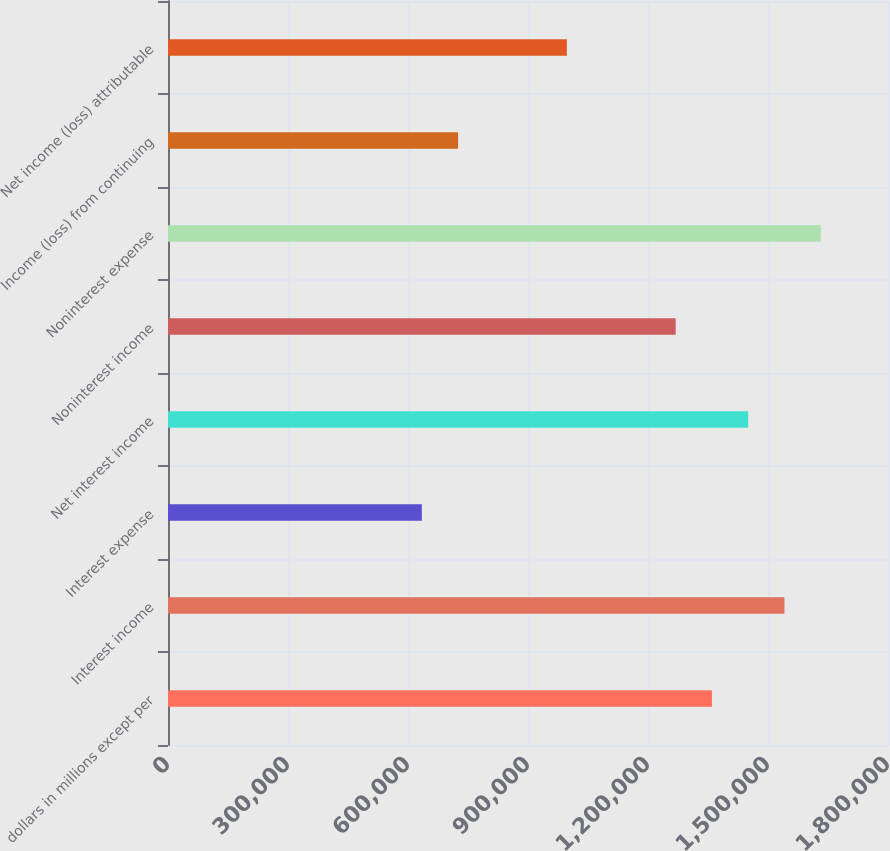Convert chart. <chart><loc_0><loc_0><loc_500><loc_500><bar_chart><fcel>dollars in millions except per<fcel>Interest income<fcel>Interest expense<fcel>Net interest income<fcel>Noninterest income<fcel>Noninterest expense<fcel>Income (loss) from continuing<fcel>Net income (loss) attributable<nl><fcel>1.35979e+06<fcel>1.54109e+06<fcel>634567<fcel>1.45044e+06<fcel>1.26913e+06<fcel>1.63174e+06<fcel>725219<fcel>997176<nl></chart> 